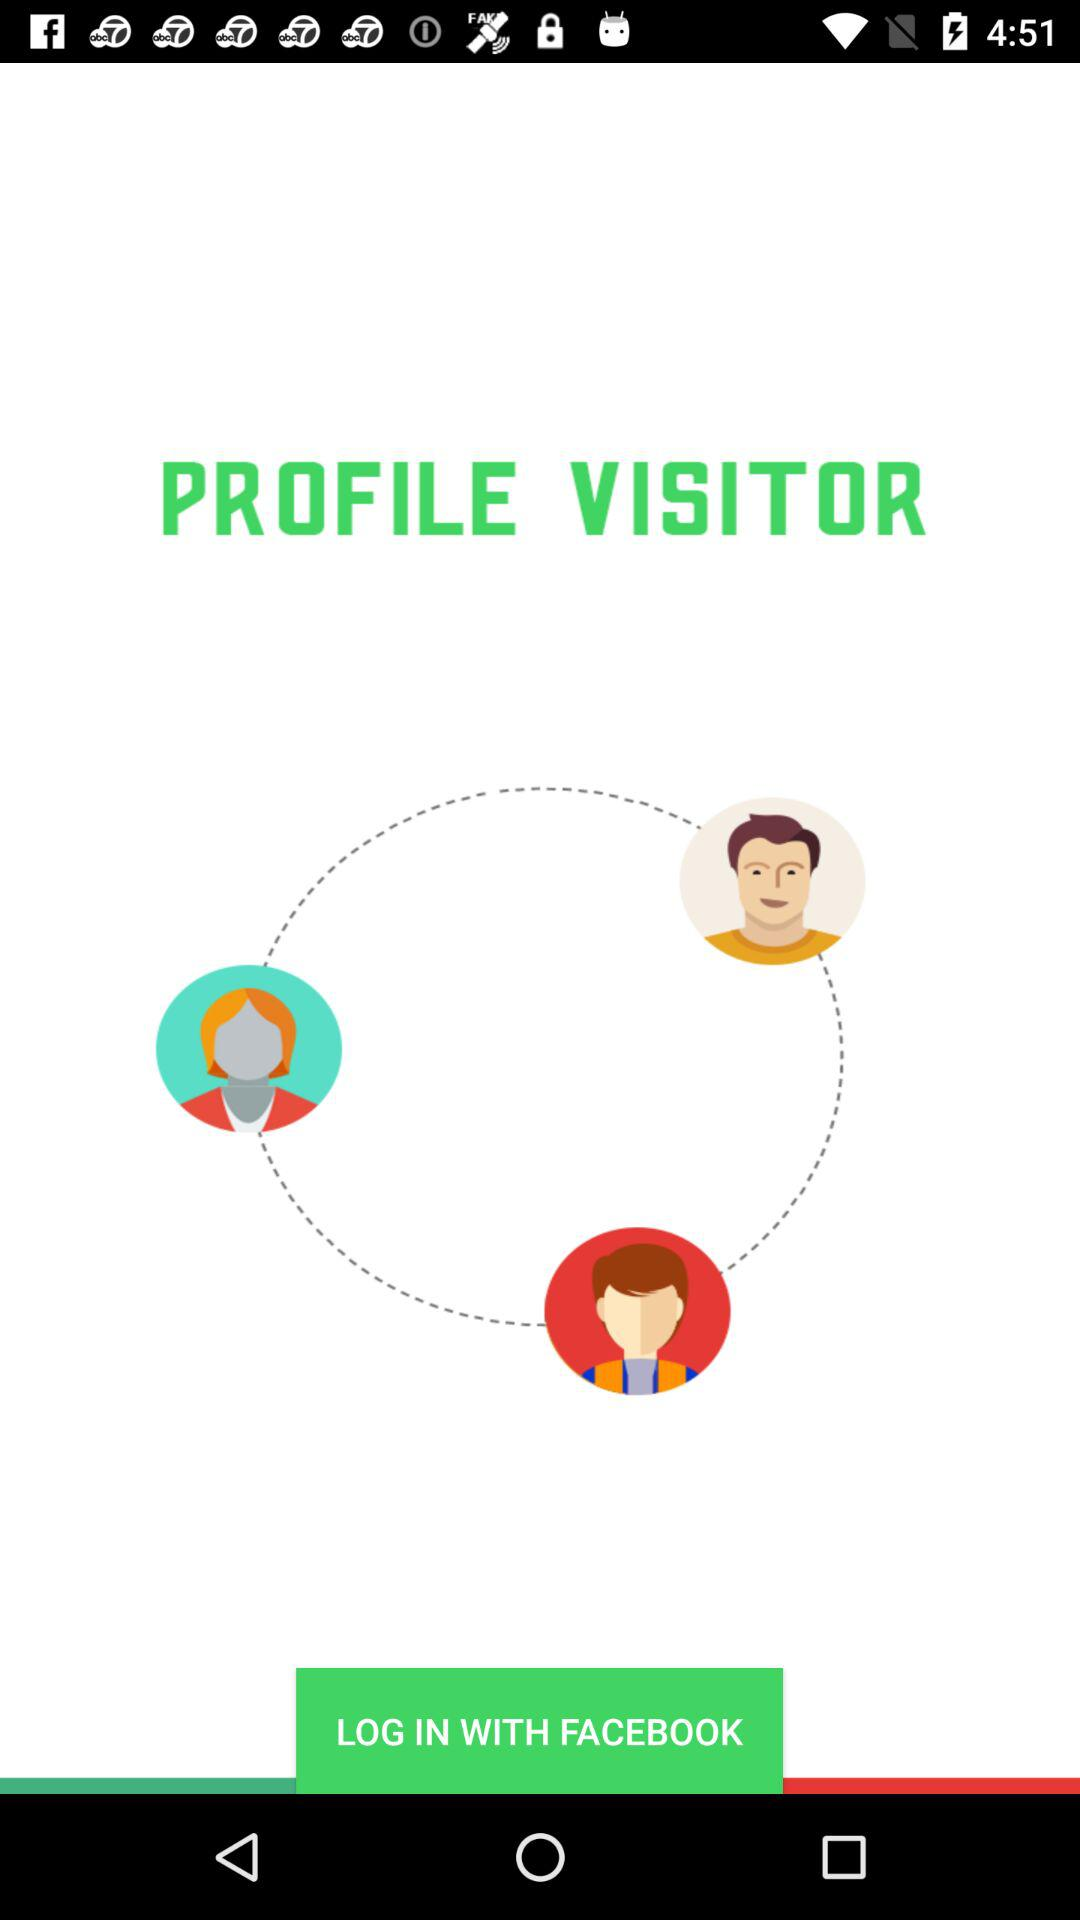How many people are connected to the profile visitor?
Answer the question using a single word or phrase. 3 